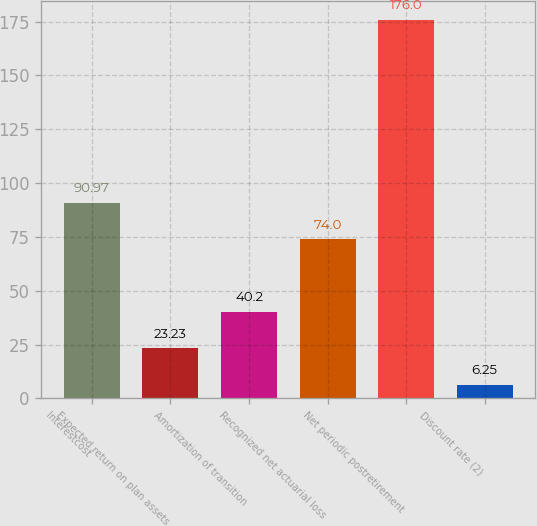Convert chart to OTSL. <chart><loc_0><loc_0><loc_500><loc_500><bar_chart><fcel>Interestcost<fcel>Expected return on plan assets<fcel>Amortization of transition<fcel>Recognized net actuarial loss<fcel>Net periodic postretirement<fcel>Discount rate (2)<nl><fcel>90.97<fcel>23.23<fcel>40.2<fcel>74<fcel>176<fcel>6.25<nl></chart> 